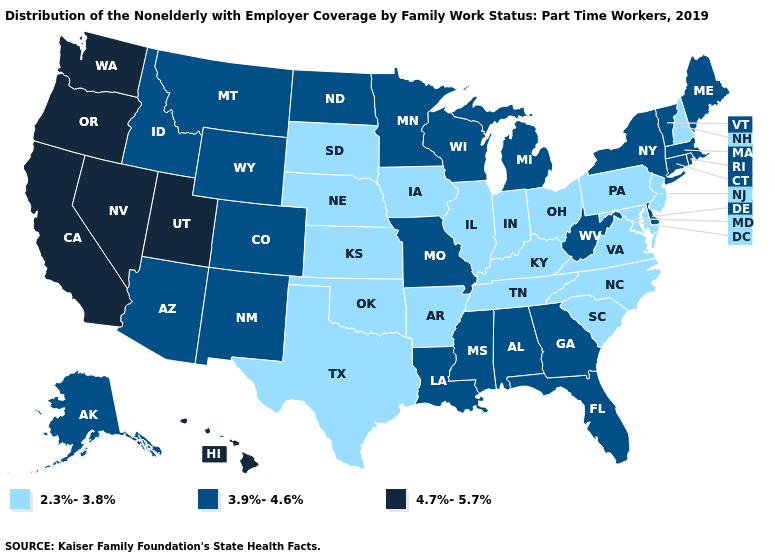Does Oregon have the highest value in the USA?
Answer briefly. Yes. How many symbols are there in the legend?
Quick response, please. 3. Name the states that have a value in the range 2.3%-3.8%?
Answer briefly. Arkansas, Illinois, Indiana, Iowa, Kansas, Kentucky, Maryland, Nebraska, New Hampshire, New Jersey, North Carolina, Ohio, Oklahoma, Pennsylvania, South Carolina, South Dakota, Tennessee, Texas, Virginia. Does the map have missing data?
Give a very brief answer. No. Name the states that have a value in the range 4.7%-5.7%?
Be succinct. California, Hawaii, Nevada, Oregon, Utah, Washington. Does Missouri have the lowest value in the MidWest?
Quick response, please. No. Among the states that border North Carolina , does Georgia have the lowest value?
Give a very brief answer. No. Does the first symbol in the legend represent the smallest category?
Keep it brief. Yes. Name the states that have a value in the range 3.9%-4.6%?
Short answer required. Alabama, Alaska, Arizona, Colorado, Connecticut, Delaware, Florida, Georgia, Idaho, Louisiana, Maine, Massachusetts, Michigan, Minnesota, Mississippi, Missouri, Montana, New Mexico, New York, North Dakota, Rhode Island, Vermont, West Virginia, Wisconsin, Wyoming. Does Rhode Island have a higher value than Texas?
Write a very short answer. Yes. What is the value of North Carolina?
Concise answer only. 2.3%-3.8%. Does the map have missing data?
Keep it brief. No. Does Vermont have the highest value in the USA?
Keep it brief. No. What is the highest value in states that border Ohio?
Answer briefly. 3.9%-4.6%. 